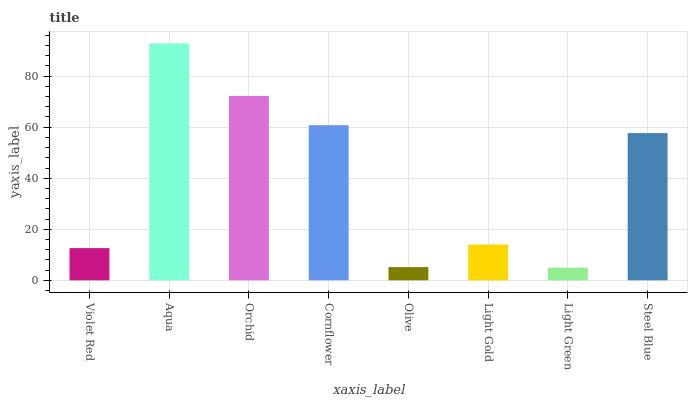Is Light Green the minimum?
Answer yes or no. Yes. Is Aqua the maximum?
Answer yes or no. Yes. Is Orchid the minimum?
Answer yes or no. No. Is Orchid the maximum?
Answer yes or no. No. Is Aqua greater than Orchid?
Answer yes or no. Yes. Is Orchid less than Aqua?
Answer yes or no. Yes. Is Orchid greater than Aqua?
Answer yes or no. No. Is Aqua less than Orchid?
Answer yes or no. No. Is Steel Blue the high median?
Answer yes or no. Yes. Is Light Gold the low median?
Answer yes or no. Yes. Is Cornflower the high median?
Answer yes or no. No. Is Cornflower the low median?
Answer yes or no. No. 